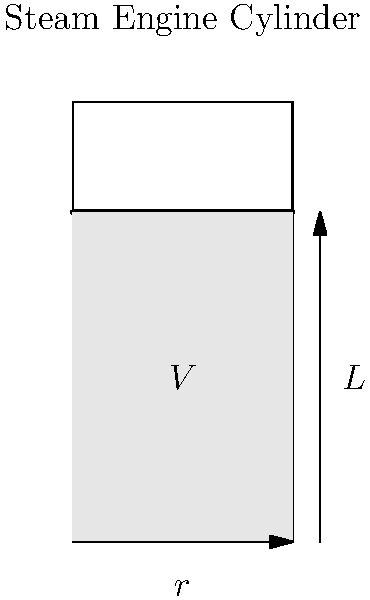Your grandfather, a retired steam engine mechanic, tells you about optimizing piston stroke length. He explains that the power output $P$ of a steam engine is proportional to the volume $V$ of the cylinder and inversely proportional to the stroke length $L$. The relationship is given by $P = k\frac{V}{L}$, where $k$ is a constant. If the cylinder has a radius $r$ and the volume is $V = \pi r^2 L$, find the optimal stroke length $L$ in terms of $r$ to maximize power output. Let's approach this step-by-step:

1) We're given that $P = k\frac{V}{L}$ and $V = \pi r^2 L$.

2) Substituting the expression for $V$ into the power equation:
   $P = k\frac{\pi r^2 L}{L} = k\pi r^2$

3) This might seem counterintuitive as $L$ cancels out, but remember that changing $L$ will affect $V$, so we need to consider the constraint that the surface area of the cylinder remains constant.

4) The surface area of the cylinder (ignoring the ends) is $2\pi r L$. Let's call this constant area $A$. So:
   $A = 2\pi r L$
   $L = \frac{A}{2\pi r}$

5) Now, substituting this into our volume equation:
   $V = \pi r^2 L = \pi r^2 (\frac{A}{2\pi r}) = \frac{Ar}{2}$

6) And now into our power equation:
   $P = k\frac{V}{L} = k\frac{\frac{Ar}{2}}{\frac{A}{2\pi r}} = k\pi r^2$

7) To maximize $P$, we need to maximize $r$. Given that $A$ is constant, from the equation in step 4, we can see that $L$ and $r$ are inversely proportional.

8) The optimal ratio between $L$ and $r$ occurs when $L = 2r$. This is because it gives the largest volume for a given surface area in a cylinder.

Therefore, the optimal stroke length $L$ is $2r$.
Answer: $L = 2r$ 